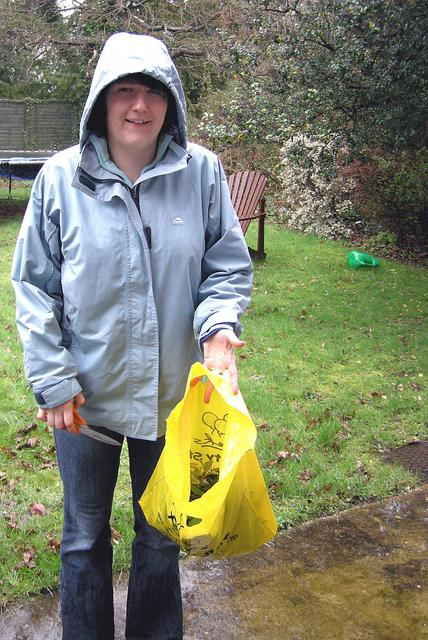What was probably stored in the container on the grass? Please explain your reasoning. detergent. A green bottle is in the grass near people picking up trash. the shape of the container is consistent with the shape of laundry detergent bottles. 